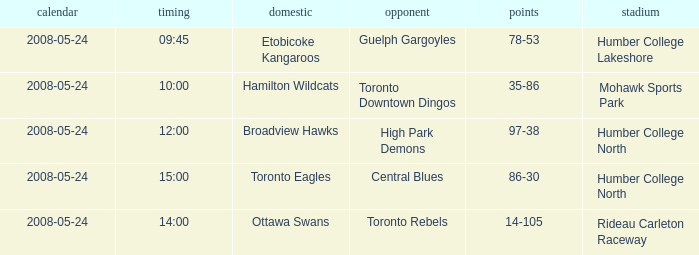On what day was the game that ended in a score of 97-38? 2008-05-24. 